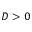<formula> <loc_0><loc_0><loc_500><loc_500>D > 0</formula> 